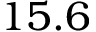<formula> <loc_0><loc_0><loc_500><loc_500>1 5 . 6</formula> 